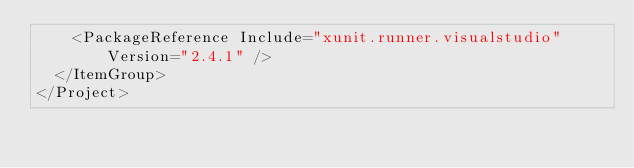Convert code to text. <code><loc_0><loc_0><loc_500><loc_500><_XML_>    <PackageReference Include="xunit.runner.visualstudio" Version="2.4.1" />
  </ItemGroup>
</Project>
</code> 